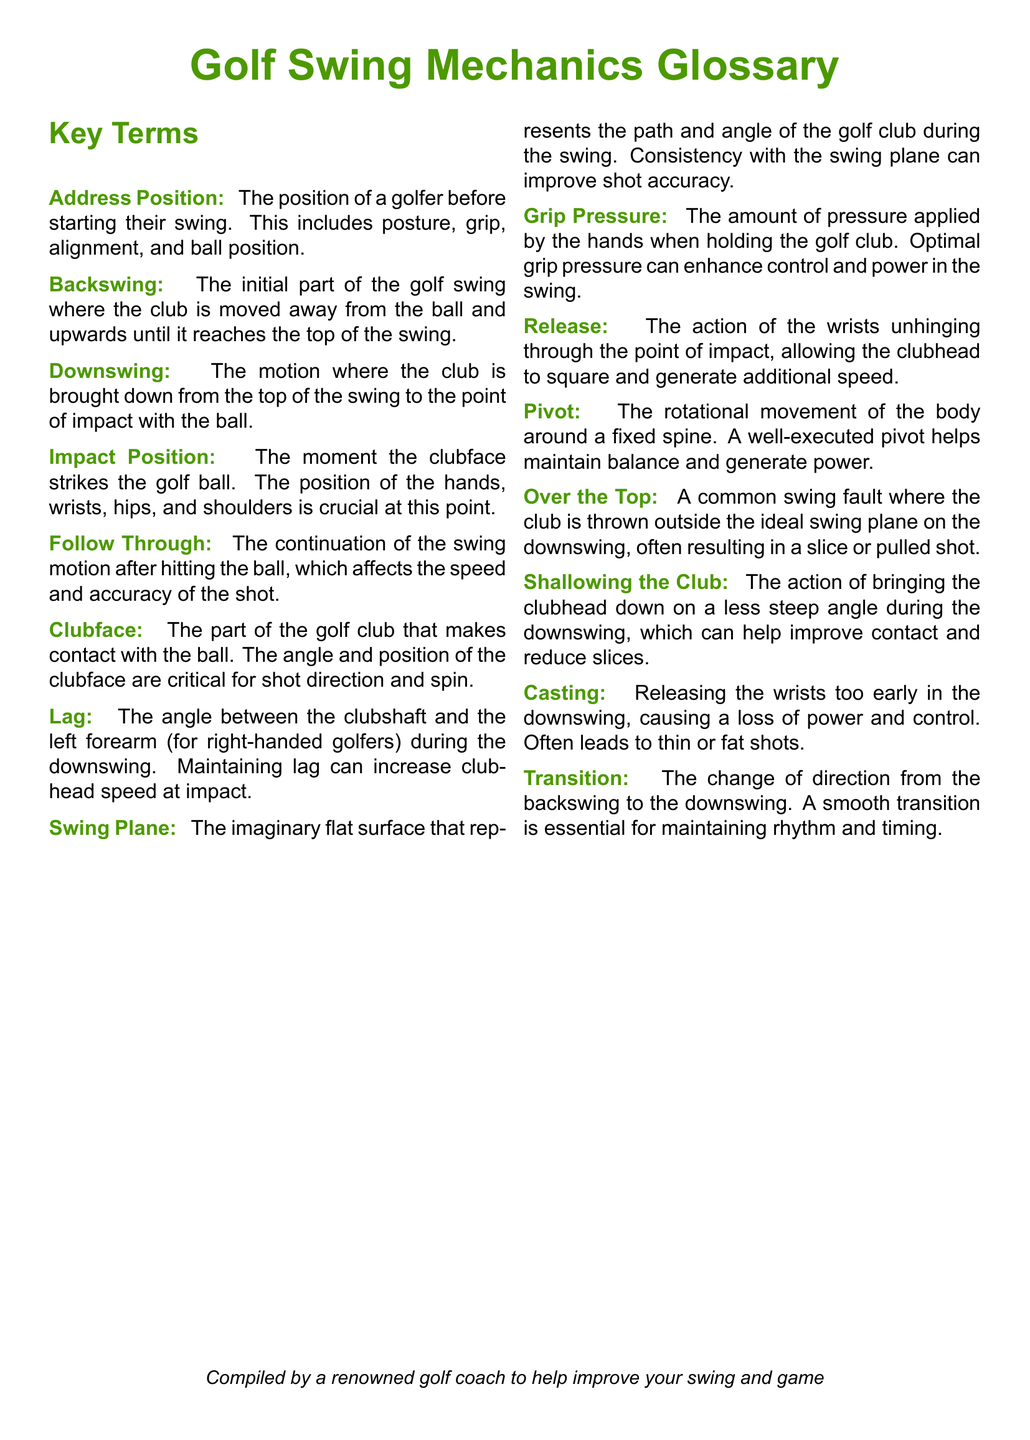What does the Address Position include? It refers to the aspects that define a golfer's position before starting their swing, including posture, grip, alignment, and ball position.
Answer: Posture, grip, alignment, ball position What is the main purpose of the Follow Through? The Follow Through is the continuation of the swing motion after hitting the ball, which is crucial for speed and accuracy.
Answer: Affect speed and accuracy What does Lag refer to in swing mechanics? Lag is the angle between the clubshaft and the left forearm during the downswing, important for increasing clubhead speed.
Answer: Angle between clubshaft and left forearm What swing fault is described as "Over the Top"? It describes a swing fault where the club moves outside the ideal swing plane on the downswing, often resulting in poor shots.
Answer: Outside the ideal swing plane What is the function of Grip Pressure in a golf swing? Grip Pressure is the force applied by the hands when holding the club, which impacts control and power in the swing.
Answer: Enhance control and power What is a common outcome of Casting in the downswing? Casting involves releasing the wrists too early, leading to a loss of power and resulting in thin or fat shots.
Answer: Loss of power and control What is defined by the term Swing Plane? Swing Plane is the imaginary flat surface representing the path and angle of the golf club during the swing.
Answer: Imaginary flat surface What term describes the transition from backswing to downswing? The transition refers to the change of direction that occurs between the two phases of the swing.
Answer: Transition What does Shallowing the Club help achieve? Shallowing the Club helps achieve a less steep angle during the downswing, improving contact and reducing slices.
Answer: Improve contact and reduce slices 